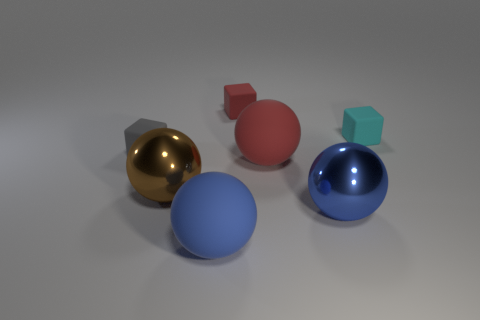Subtract 1 balls. How many balls are left? 3 Add 1 spheres. How many objects exist? 8 Subtract all blocks. How many objects are left? 4 Add 1 tiny cyan objects. How many tiny cyan objects exist? 2 Subtract 0 green spheres. How many objects are left? 7 Subtract all tiny green matte cylinders. Subtract all cubes. How many objects are left? 4 Add 2 cyan blocks. How many cyan blocks are left? 3 